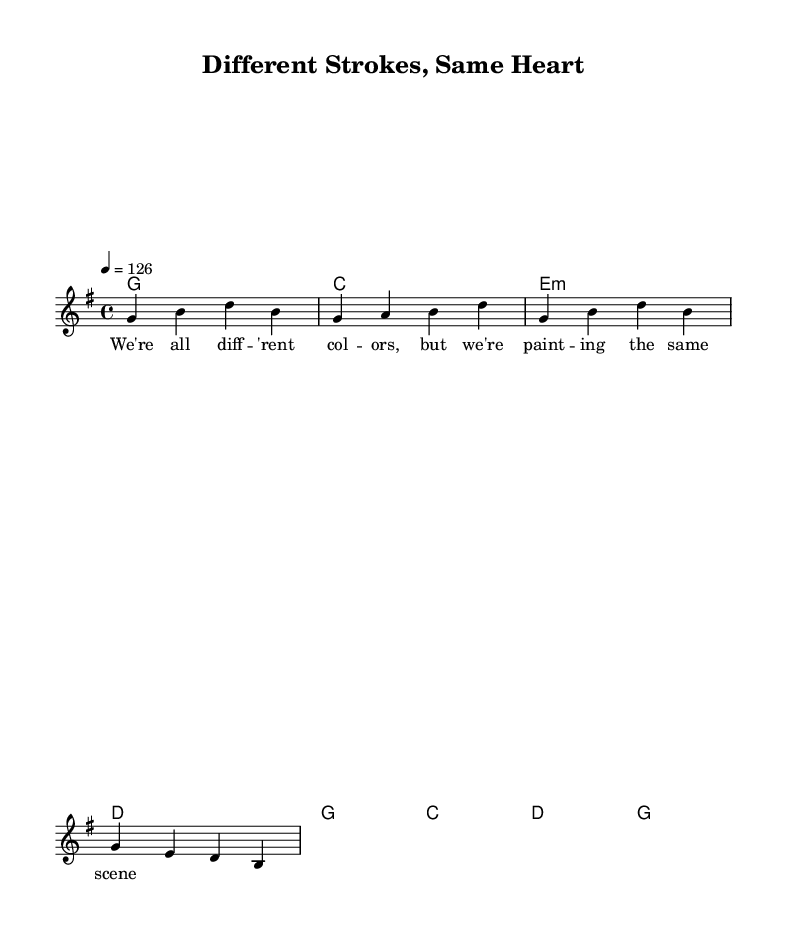What is the key signature of this music? The key signature is G major, which has one sharp (F#). This is identified by looking at the key signature at the beginning of the staff.
Answer: G major What is the time signature of the piece? The time signature is 4/4, indicated right after the key signature at the beginning of the score. This means there are four beats in each measure and a quarter note receives one beat.
Answer: 4/4 What is the tempo marking for this music? The tempo is marked as 126, which is indicated in the score’s tempo section. This typically means there are 126 beats per minute.
Answer: 126 How many measures are in the melody? There are four measures in the melody, as counted by the vertical bar lines that separate the distinct measures in the staff.
Answer: 4 What chord is played in the first measure? The chord in the first measure is G major, which is represented by the "g1" chord in the harmonies section at the beginning of the score.
Answer: G What lyrical theme is represented in the lyrics? The lyrics convey themes of diversity and unity, as expressed in the lines that emphasize different colors and a shared scene. This can be understood through the content of the text.
Answer: Diversity Which musical genre does this piece belong to? The piece belongs to the country rock genre, a characteristic style that combines elements of country music with rock rhythms and instrumentation, as indicated by the title and the upbeat nature of the music.
Answer: Country rock 